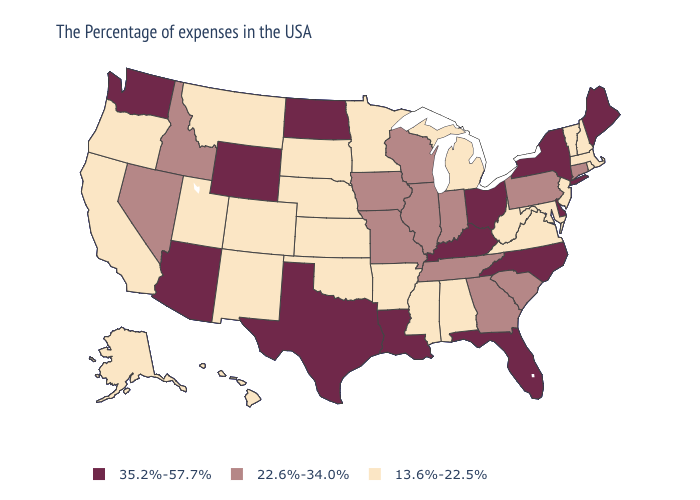What is the value of Montana?
Concise answer only. 13.6%-22.5%. Among the states that border Oklahoma , does Colorado have the highest value?
Give a very brief answer. No. Among the states that border Arkansas , does Louisiana have the lowest value?
Concise answer only. No. Among the states that border Minnesota , which have the lowest value?
Give a very brief answer. South Dakota. Does New Jersey have the highest value in the USA?
Write a very short answer. No. Which states have the lowest value in the USA?
Quick response, please. Massachusetts, Rhode Island, New Hampshire, Vermont, New Jersey, Maryland, Virginia, West Virginia, Michigan, Alabama, Mississippi, Arkansas, Minnesota, Kansas, Nebraska, Oklahoma, South Dakota, Colorado, New Mexico, Utah, Montana, California, Oregon, Alaska, Hawaii. Name the states that have a value in the range 35.2%-57.7%?
Concise answer only. Maine, New York, Delaware, North Carolina, Ohio, Florida, Kentucky, Louisiana, Texas, North Dakota, Wyoming, Arizona, Washington. What is the value of Colorado?
Give a very brief answer. 13.6%-22.5%. Does Delaware have the lowest value in the USA?
Be succinct. No. Name the states that have a value in the range 22.6%-34.0%?
Be succinct. Connecticut, Pennsylvania, South Carolina, Georgia, Indiana, Tennessee, Wisconsin, Illinois, Missouri, Iowa, Idaho, Nevada. What is the value of Arizona?
Be succinct. 35.2%-57.7%. Does Missouri have the highest value in the MidWest?
Short answer required. No. Name the states that have a value in the range 13.6%-22.5%?
Write a very short answer. Massachusetts, Rhode Island, New Hampshire, Vermont, New Jersey, Maryland, Virginia, West Virginia, Michigan, Alabama, Mississippi, Arkansas, Minnesota, Kansas, Nebraska, Oklahoma, South Dakota, Colorado, New Mexico, Utah, Montana, California, Oregon, Alaska, Hawaii. What is the value of Wyoming?
Give a very brief answer. 35.2%-57.7%. 